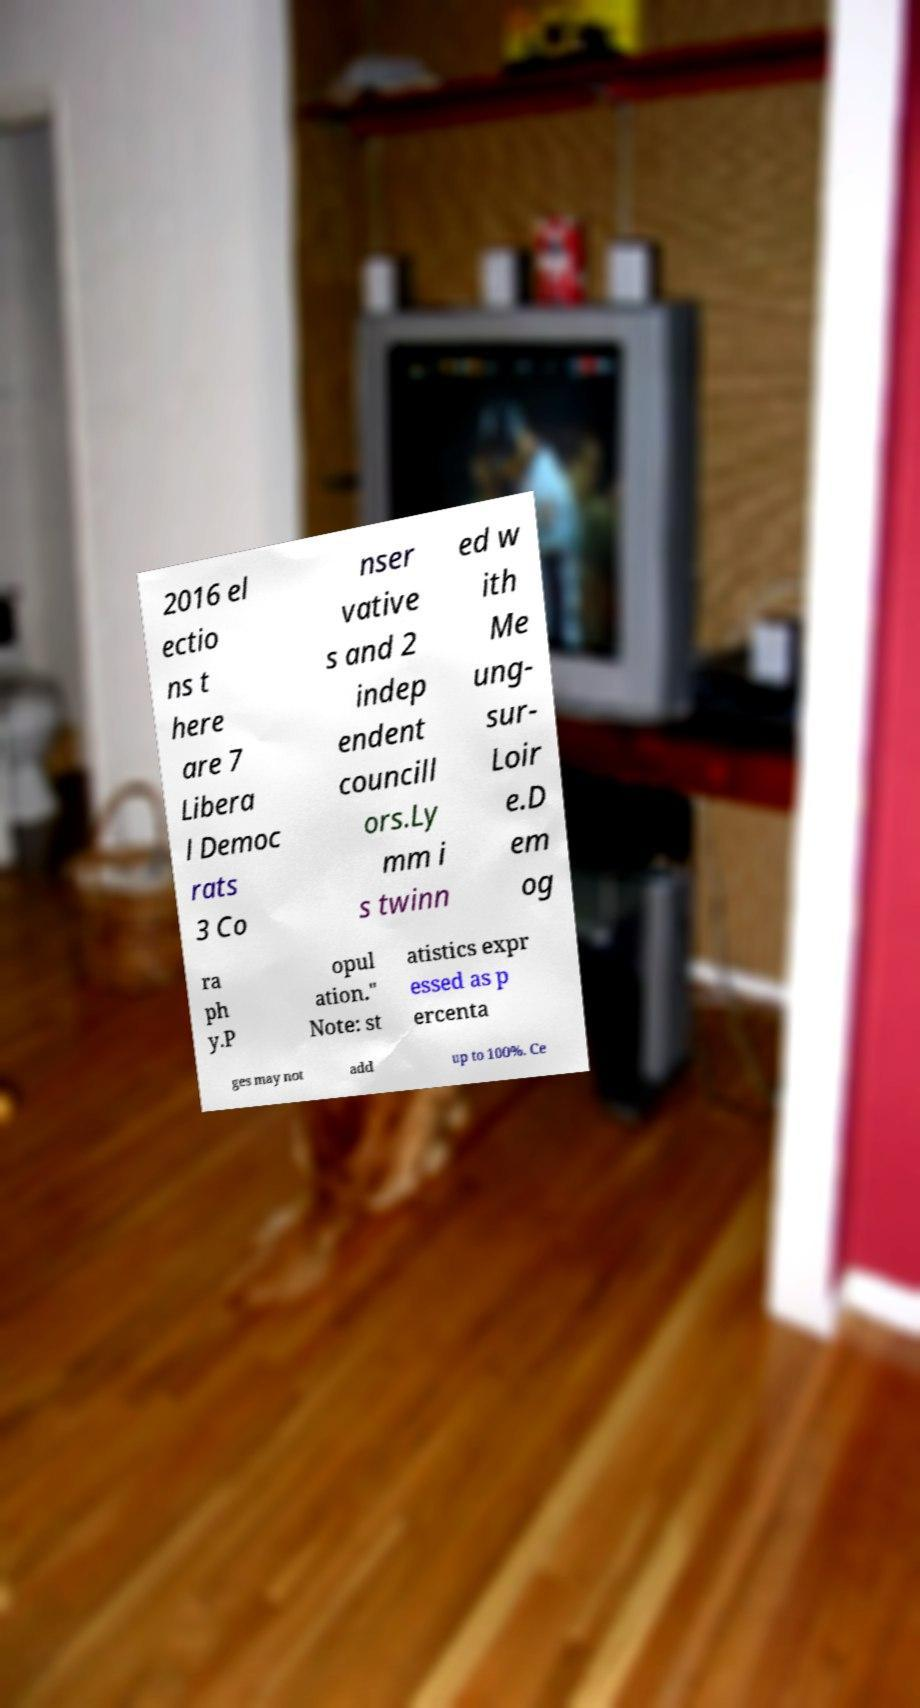Can you accurately transcribe the text from the provided image for me? 2016 el ectio ns t here are 7 Libera l Democ rats 3 Co nser vative s and 2 indep endent councill ors.Ly mm i s twinn ed w ith Me ung- sur- Loir e.D em og ra ph y.P opul ation." Note: st atistics expr essed as p ercenta ges may not add up to 100%. Ce 